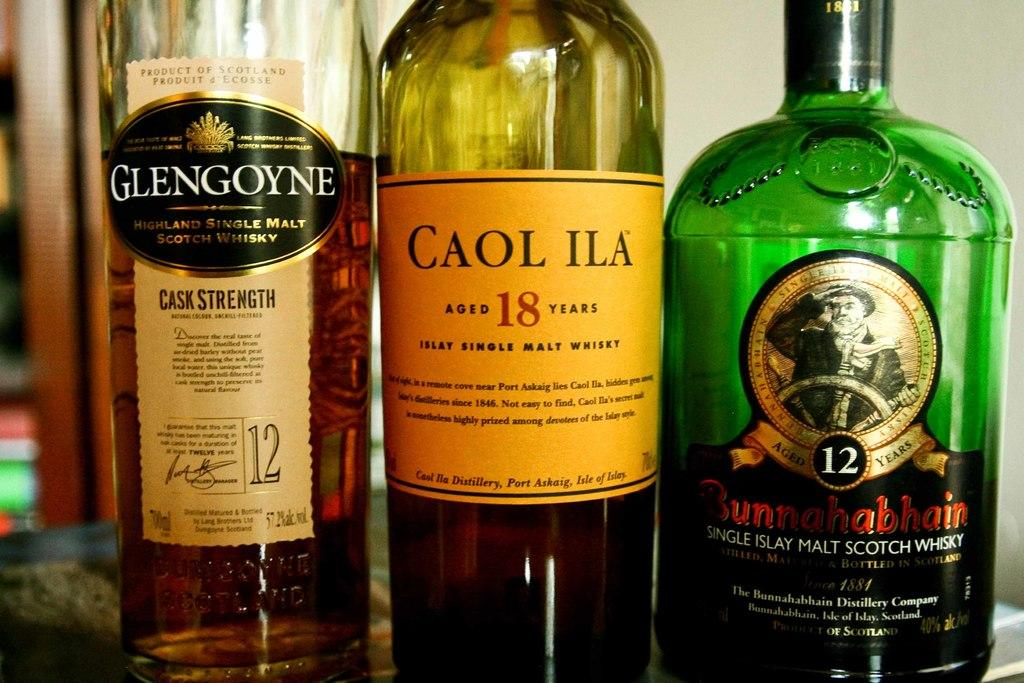What type of beverages are in the bottles visible in the image? The bottles in the image contain alcohol. Where are the bottles of alcohol located? The bottles of alcohol are on a table. What type of beef is being served on the hydrant in the image? There is no hydrant or beef present in the image; it only features bottles of alcohol on a table. 